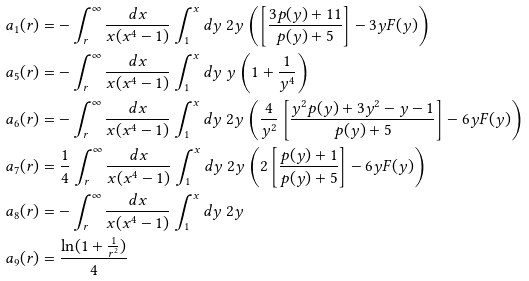Convert formula to latex. <formula><loc_0><loc_0><loc_500><loc_500>a _ { 1 } ( r ) & = - \int _ { r } ^ { \infty } \frac { d x } { x ( x ^ { 4 } - 1 ) } \int _ { 1 } ^ { x } d y \ 2 y \left ( \left [ \frac { 3 p ( y ) + 1 1 } { p ( y ) + 5 } \right ] - 3 y F ( y ) \right ) \\ a _ { 5 } ( r ) & = - \int _ { r } ^ { \infty } \frac { d x } { x ( x ^ { 4 } - 1 ) } \int _ { 1 } ^ { x } d y \ y \left ( 1 + \frac { 1 } { y ^ { 4 } } \right ) \\ a _ { 6 } ( r ) & = - \int _ { r } ^ { \infty } \frac { d x } { x ( x ^ { 4 } - 1 ) } \int _ { 1 } ^ { x } d y \ 2 y \left ( \frac { 4 } { y ^ { 2 } } \left [ \frac { y ^ { 2 } p ( y ) + 3 y ^ { 2 } - y - 1 } { p ( y ) + 5 } \right ] - 6 y F ( y ) \right ) \\ a _ { 7 } ( r ) & = \frac { 1 } { 4 } \int _ { r } ^ { \infty } \frac { d x } { x ( x ^ { 4 } - 1 ) } \int _ { 1 } ^ { x } d y \ 2 y \left ( 2 \left [ \frac { p ( y ) + 1 } { p ( y ) + 5 } \right ] - 6 y F ( y ) \right ) \\ a _ { 8 } ( r ) & = - \int _ { r } ^ { \infty } \frac { d x } { x ( x ^ { 4 } - 1 ) } \int _ { 1 } ^ { x } d y \ 2 y \\ a _ { 9 } ( r ) & = \frac { \ln ( 1 + \frac { 1 } { r ^ { 2 } } ) } { 4 } \\</formula> 